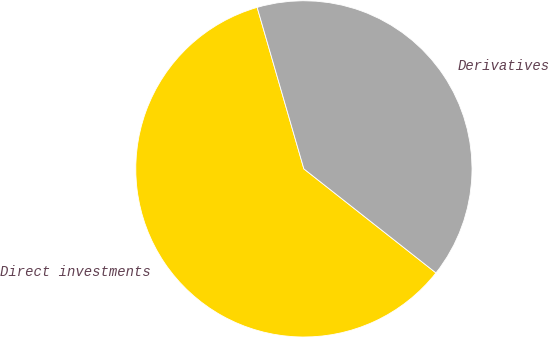Convert chart to OTSL. <chart><loc_0><loc_0><loc_500><loc_500><pie_chart><fcel>Direct investments<fcel>Derivatives<nl><fcel>59.9%<fcel>40.1%<nl></chart> 